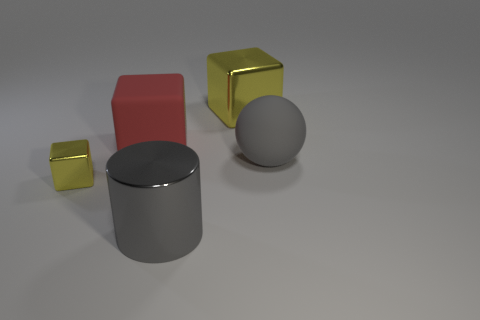Add 1 big purple metal cylinders. How many objects exist? 6 Subtract all yellow cubes. How many cubes are left? 1 Subtract all small blocks. How many blocks are left? 2 Subtract all balls. How many objects are left? 4 Subtract all green cylinders. How many yellow cubes are left? 2 Subtract all small gray metal cylinders. Subtract all small blocks. How many objects are left? 4 Add 1 small yellow metallic blocks. How many small yellow metallic blocks are left? 2 Add 1 tiny gray cubes. How many tiny gray cubes exist? 1 Subtract 0 purple cylinders. How many objects are left? 5 Subtract all red blocks. Subtract all yellow cylinders. How many blocks are left? 2 